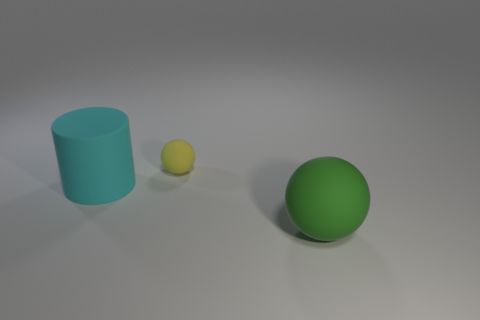Are there any other things that have the same size as the yellow rubber object?
Ensure brevity in your answer.  No. Do the small sphere and the object to the left of the yellow rubber thing have the same color?
Offer a very short reply. No. There is a tiny yellow object that is made of the same material as the cylinder; what is its shape?
Your answer should be compact. Sphere. What number of cyan things are there?
Your answer should be compact. 1. How many objects are matte things behind the cyan cylinder or green rubber things?
Offer a terse response. 2. What number of tiny objects are red blocks or matte things?
Give a very brief answer. 1. Are there more gray cubes than cyan cylinders?
Your answer should be compact. No. Is the material of the large cyan cylinder the same as the tiny object?
Your answer should be very brief. Yes. Is the number of things behind the large cylinder greater than the number of red spheres?
Your answer should be very brief. Yes. What number of other small things have the same shape as the green rubber object?
Give a very brief answer. 1. 